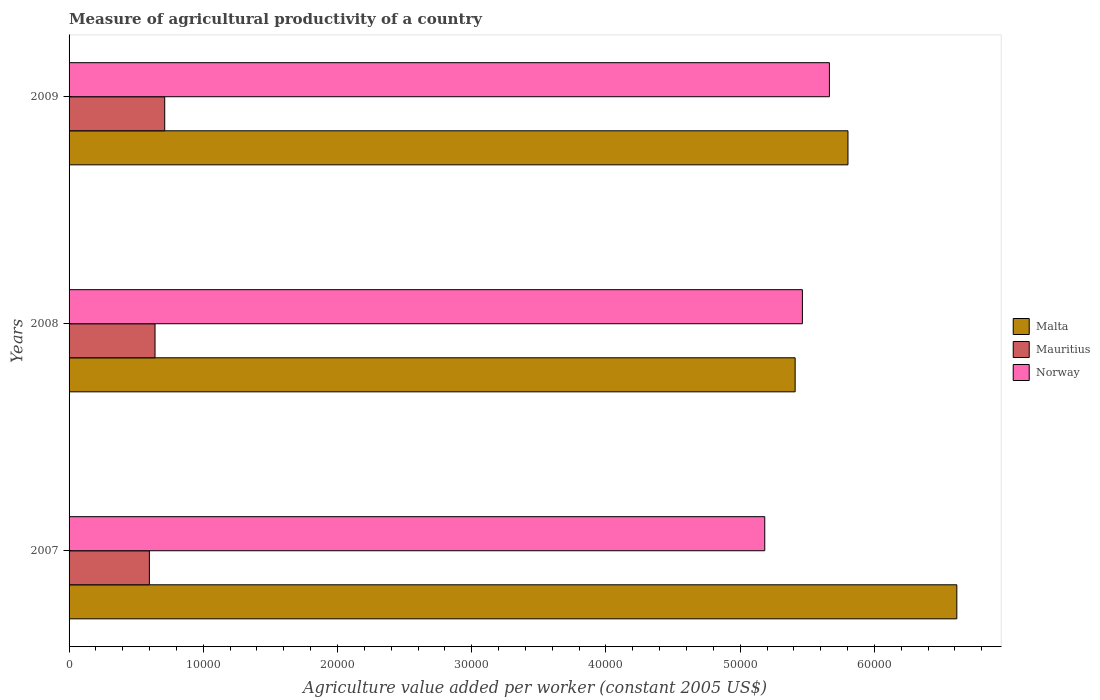How many different coloured bars are there?
Keep it short and to the point. 3. What is the label of the 3rd group of bars from the top?
Make the answer very short. 2007. What is the measure of agricultural productivity in Malta in 2008?
Offer a terse response. 5.41e+04. Across all years, what is the maximum measure of agricultural productivity in Mauritius?
Provide a succinct answer. 7126.5. Across all years, what is the minimum measure of agricultural productivity in Norway?
Your answer should be compact. 5.18e+04. In which year was the measure of agricultural productivity in Mauritius minimum?
Your answer should be compact. 2007. What is the total measure of agricultural productivity in Mauritius in the graph?
Make the answer very short. 1.95e+04. What is the difference between the measure of agricultural productivity in Malta in 2007 and that in 2009?
Offer a terse response. 8109.75. What is the difference between the measure of agricultural productivity in Norway in 2009 and the measure of agricultural productivity in Malta in 2008?
Offer a very short reply. 2553.59. What is the average measure of agricultural productivity in Norway per year?
Your answer should be compact. 5.44e+04. In the year 2007, what is the difference between the measure of agricultural productivity in Malta and measure of agricultural productivity in Mauritius?
Give a very brief answer. 6.02e+04. What is the ratio of the measure of agricultural productivity in Mauritius in 2007 to that in 2008?
Your response must be concise. 0.93. Is the measure of agricultural productivity in Norway in 2007 less than that in 2009?
Provide a short and direct response. Yes. Is the difference between the measure of agricultural productivity in Malta in 2007 and 2009 greater than the difference between the measure of agricultural productivity in Mauritius in 2007 and 2009?
Your answer should be compact. Yes. What is the difference between the highest and the second highest measure of agricultural productivity in Norway?
Provide a short and direct response. 2012.64. What is the difference between the highest and the lowest measure of agricultural productivity in Mauritius?
Your answer should be very brief. 1143.65. In how many years, is the measure of agricultural productivity in Malta greater than the average measure of agricultural productivity in Malta taken over all years?
Your answer should be compact. 1. Is the sum of the measure of agricultural productivity in Malta in 2008 and 2009 greater than the maximum measure of agricultural productivity in Norway across all years?
Offer a terse response. Yes. What does the 2nd bar from the top in 2007 represents?
Your answer should be very brief. Mauritius. What does the 2nd bar from the bottom in 2007 represents?
Ensure brevity in your answer.  Mauritius. How many bars are there?
Your response must be concise. 9. Are all the bars in the graph horizontal?
Ensure brevity in your answer.  Yes. Are the values on the major ticks of X-axis written in scientific E-notation?
Offer a terse response. No. Does the graph contain any zero values?
Your response must be concise. No. Does the graph contain grids?
Your response must be concise. No. Where does the legend appear in the graph?
Your answer should be very brief. Center right. How many legend labels are there?
Your answer should be very brief. 3. How are the legend labels stacked?
Offer a terse response. Vertical. What is the title of the graph?
Give a very brief answer. Measure of agricultural productivity of a country. What is the label or title of the X-axis?
Ensure brevity in your answer.  Agriculture value added per worker (constant 2005 US$). What is the Agriculture value added per worker (constant 2005 US$) in Malta in 2007?
Your answer should be very brief. 6.61e+04. What is the Agriculture value added per worker (constant 2005 US$) of Mauritius in 2007?
Your answer should be very brief. 5982.86. What is the Agriculture value added per worker (constant 2005 US$) of Norway in 2007?
Your answer should be very brief. 5.18e+04. What is the Agriculture value added per worker (constant 2005 US$) of Malta in 2008?
Make the answer very short. 5.41e+04. What is the Agriculture value added per worker (constant 2005 US$) of Mauritius in 2008?
Offer a very short reply. 6404. What is the Agriculture value added per worker (constant 2005 US$) of Norway in 2008?
Ensure brevity in your answer.  5.46e+04. What is the Agriculture value added per worker (constant 2005 US$) in Malta in 2009?
Provide a short and direct response. 5.80e+04. What is the Agriculture value added per worker (constant 2005 US$) in Mauritius in 2009?
Your answer should be very brief. 7126.5. What is the Agriculture value added per worker (constant 2005 US$) in Norway in 2009?
Your answer should be very brief. 5.66e+04. Across all years, what is the maximum Agriculture value added per worker (constant 2005 US$) in Malta?
Make the answer very short. 6.61e+04. Across all years, what is the maximum Agriculture value added per worker (constant 2005 US$) of Mauritius?
Offer a very short reply. 7126.5. Across all years, what is the maximum Agriculture value added per worker (constant 2005 US$) of Norway?
Offer a terse response. 5.66e+04. Across all years, what is the minimum Agriculture value added per worker (constant 2005 US$) of Malta?
Offer a very short reply. 5.41e+04. Across all years, what is the minimum Agriculture value added per worker (constant 2005 US$) in Mauritius?
Provide a short and direct response. 5982.86. Across all years, what is the minimum Agriculture value added per worker (constant 2005 US$) in Norway?
Make the answer very short. 5.18e+04. What is the total Agriculture value added per worker (constant 2005 US$) of Malta in the graph?
Make the answer very short. 1.78e+05. What is the total Agriculture value added per worker (constant 2005 US$) in Mauritius in the graph?
Make the answer very short. 1.95e+04. What is the total Agriculture value added per worker (constant 2005 US$) of Norway in the graph?
Your response must be concise. 1.63e+05. What is the difference between the Agriculture value added per worker (constant 2005 US$) of Malta in 2007 and that in 2008?
Keep it short and to the point. 1.20e+04. What is the difference between the Agriculture value added per worker (constant 2005 US$) of Mauritius in 2007 and that in 2008?
Make the answer very short. -421.15. What is the difference between the Agriculture value added per worker (constant 2005 US$) of Norway in 2007 and that in 2008?
Offer a very short reply. -2803.94. What is the difference between the Agriculture value added per worker (constant 2005 US$) of Malta in 2007 and that in 2009?
Your answer should be very brief. 8109.75. What is the difference between the Agriculture value added per worker (constant 2005 US$) of Mauritius in 2007 and that in 2009?
Your answer should be very brief. -1143.65. What is the difference between the Agriculture value added per worker (constant 2005 US$) of Norway in 2007 and that in 2009?
Provide a short and direct response. -4816.58. What is the difference between the Agriculture value added per worker (constant 2005 US$) of Malta in 2008 and that in 2009?
Provide a succinct answer. -3936.57. What is the difference between the Agriculture value added per worker (constant 2005 US$) in Mauritius in 2008 and that in 2009?
Your response must be concise. -722.5. What is the difference between the Agriculture value added per worker (constant 2005 US$) in Norway in 2008 and that in 2009?
Your answer should be very brief. -2012.64. What is the difference between the Agriculture value added per worker (constant 2005 US$) of Malta in 2007 and the Agriculture value added per worker (constant 2005 US$) of Mauritius in 2008?
Your answer should be compact. 5.97e+04. What is the difference between the Agriculture value added per worker (constant 2005 US$) in Malta in 2007 and the Agriculture value added per worker (constant 2005 US$) in Norway in 2008?
Give a very brief answer. 1.15e+04. What is the difference between the Agriculture value added per worker (constant 2005 US$) in Mauritius in 2007 and the Agriculture value added per worker (constant 2005 US$) in Norway in 2008?
Offer a very short reply. -4.87e+04. What is the difference between the Agriculture value added per worker (constant 2005 US$) in Malta in 2007 and the Agriculture value added per worker (constant 2005 US$) in Mauritius in 2009?
Offer a terse response. 5.90e+04. What is the difference between the Agriculture value added per worker (constant 2005 US$) in Malta in 2007 and the Agriculture value added per worker (constant 2005 US$) in Norway in 2009?
Your answer should be very brief. 9492.73. What is the difference between the Agriculture value added per worker (constant 2005 US$) in Mauritius in 2007 and the Agriculture value added per worker (constant 2005 US$) in Norway in 2009?
Your answer should be very brief. -5.07e+04. What is the difference between the Agriculture value added per worker (constant 2005 US$) of Malta in 2008 and the Agriculture value added per worker (constant 2005 US$) of Mauritius in 2009?
Your answer should be very brief. 4.70e+04. What is the difference between the Agriculture value added per worker (constant 2005 US$) of Malta in 2008 and the Agriculture value added per worker (constant 2005 US$) of Norway in 2009?
Your answer should be compact. -2553.59. What is the difference between the Agriculture value added per worker (constant 2005 US$) in Mauritius in 2008 and the Agriculture value added per worker (constant 2005 US$) in Norway in 2009?
Ensure brevity in your answer.  -5.02e+04. What is the average Agriculture value added per worker (constant 2005 US$) of Malta per year?
Ensure brevity in your answer.  5.94e+04. What is the average Agriculture value added per worker (constant 2005 US$) in Mauritius per year?
Ensure brevity in your answer.  6504.46. What is the average Agriculture value added per worker (constant 2005 US$) of Norway per year?
Your response must be concise. 5.44e+04. In the year 2007, what is the difference between the Agriculture value added per worker (constant 2005 US$) in Malta and Agriculture value added per worker (constant 2005 US$) in Mauritius?
Ensure brevity in your answer.  6.02e+04. In the year 2007, what is the difference between the Agriculture value added per worker (constant 2005 US$) of Malta and Agriculture value added per worker (constant 2005 US$) of Norway?
Your answer should be compact. 1.43e+04. In the year 2007, what is the difference between the Agriculture value added per worker (constant 2005 US$) in Mauritius and Agriculture value added per worker (constant 2005 US$) in Norway?
Provide a succinct answer. -4.58e+04. In the year 2008, what is the difference between the Agriculture value added per worker (constant 2005 US$) of Malta and Agriculture value added per worker (constant 2005 US$) of Mauritius?
Offer a terse response. 4.77e+04. In the year 2008, what is the difference between the Agriculture value added per worker (constant 2005 US$) of Malta and Agriculture value added per worker (constant 2005 US$) of Norway?
Provide a short and direct response. -540.95. In the year 2008, what is the difference between the Agriculture value added per worker (constant 2005 US$) in Mauritius and Agriculture value added per worker (constant 2005 US$) in Norway?
Provide a short and direct response. -4.82e+04. In the year 2009, what is the difference between the Agriculture value added per worker (constant 2005 US$) in Malta and Agriculture value added per worker (constant 2005 US$) in Mauritius?
Your answer should be very brief. 5.09e+04. In the year 2009, what is the difference between the Agriculture value added per worker (constant 2005 US$) in Malta and Agriculture value added per worker (constant 2005 US$) in Norway?
Your answer should be very brief. 1382.98. In the year 2009, what is the difference between the Agriculture value added per worker (constant 2005 US$) of Mauritius and Agriculture value added per worker (constant 2005 US$) of Norway?
Make the answer very short. -4.95e+04. What is the ratio of the Agriculture value added per worker (constant 2005 US$) in Malta in 2007 to that in 2008?
Provide a short and direct response. 1.22. What is the ratio of the Agriculture value added per worker (constant 2005 US$) of Mauritius in 2007 to that in 2008?
Offer a terse response. 0.93. What is the ratio of the Agriculture value added per worker (constant 2005 US$) of Norway in 2007 to that in 2008?
Provide a succinct answer. 0.95. What is the ratio of the Agriculture value added per worker (constant 2005 US$) in Malta in 2007 to that in 2009?
Make the answer very short. 1.14. What is the ratio of the Agriculture value added per worker (constant 2005 US$) of Mauritius in 2007 to that in 2009?
Your response must be concise. 0.84. What is the ratio of the Agriculture value added per worker (constant 2005 US$) in Norway in 2007 to that in 2009?
Make the answer very short. 0.92. What is the ratio of the Agriculture value added per worker (constant 2005 US$) of Malta in 2008 to that in 2009?
Your answer should be very brief. 0.93. What is the ratio of the Agriculture value added per worker (constant 2005 US$) in Mauritius in 2008 to that in 2009?
Make the answer very short. 0.9. What is the ratio of the Agriculture value added per worker (constant 2005 US$) of Norway in 2008 to that in 2009?
Your answer should be very brief. 0.96. What is the difference between the highest and the second highest Agriculture value added per worker (constant 2005 US$) of Malta?
Your response must be concise. 8109.75. What is the difference between the highest and the second highest Agriculture value added per worker (constant 2005 US$) in Mauritius?
Your answer should be very brief. 722.5. What is the difference between the highest and the second highest Agriculture value added per worker (constant 2005 US$) in Norway?
Offer a very short reply. 2012.64. What is the difference between the highest and the lowest Agriculture value added per worker (constant 2005 US$) of Malta?
Keep it short and to the point. 1.20e+04. What is the difference between the highest and the lowest Agriculture value added per worker (constant 2005 US$) of Mauritius?
Keep it short and to the point. 1143.65. What is the difference between the highest and the lowest Agriculture value added per worker (constant 2005 US$) in Norway?
Ensure brevity in your answer.  4816.58. 